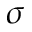Convert formula to latex. <formula><loc_0><loc_0><loc_500><loc_500>\sigma</formula> 